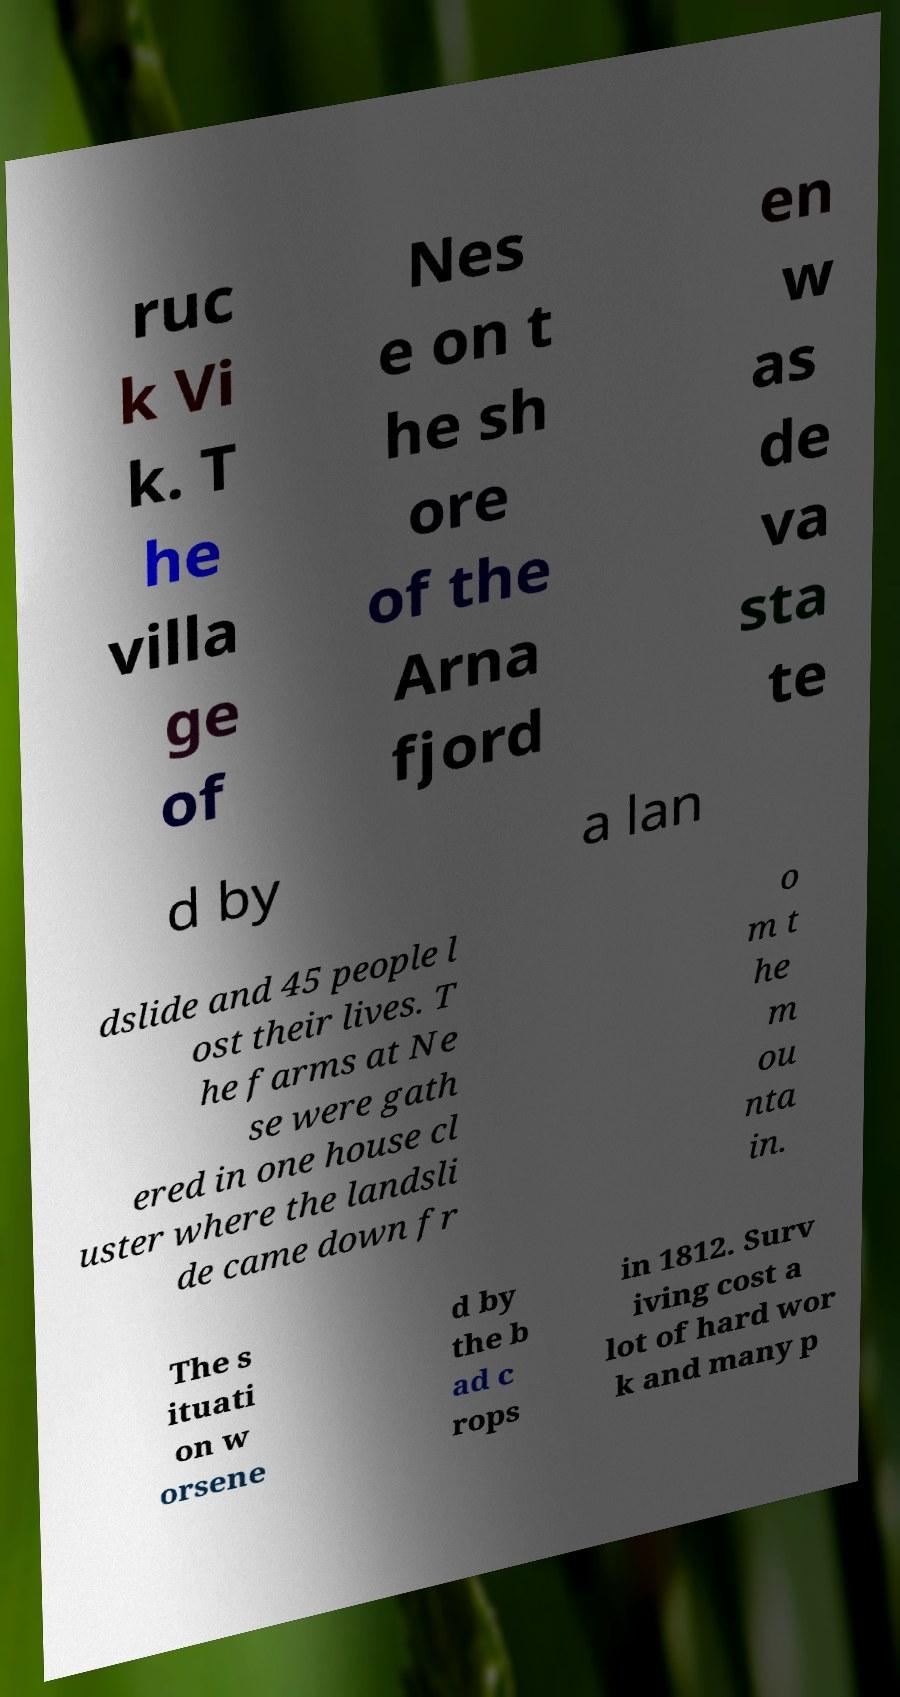I need the written content from this picture converted into text. Can you do that? ruc k Vi k. T he villa ge of Nes e on t he sh ore of the Arna fjord en w as de va sta te d by a lan dslide and 45 people l ost their lives. T he farms at Ne se were gath ered in one house cl uster where the landsli de came down fr o m t he m ou nta in. The s ituati on w orsene d by the b ad c rops in 1812. Surv iving cost a lot of hard wor k and many p 